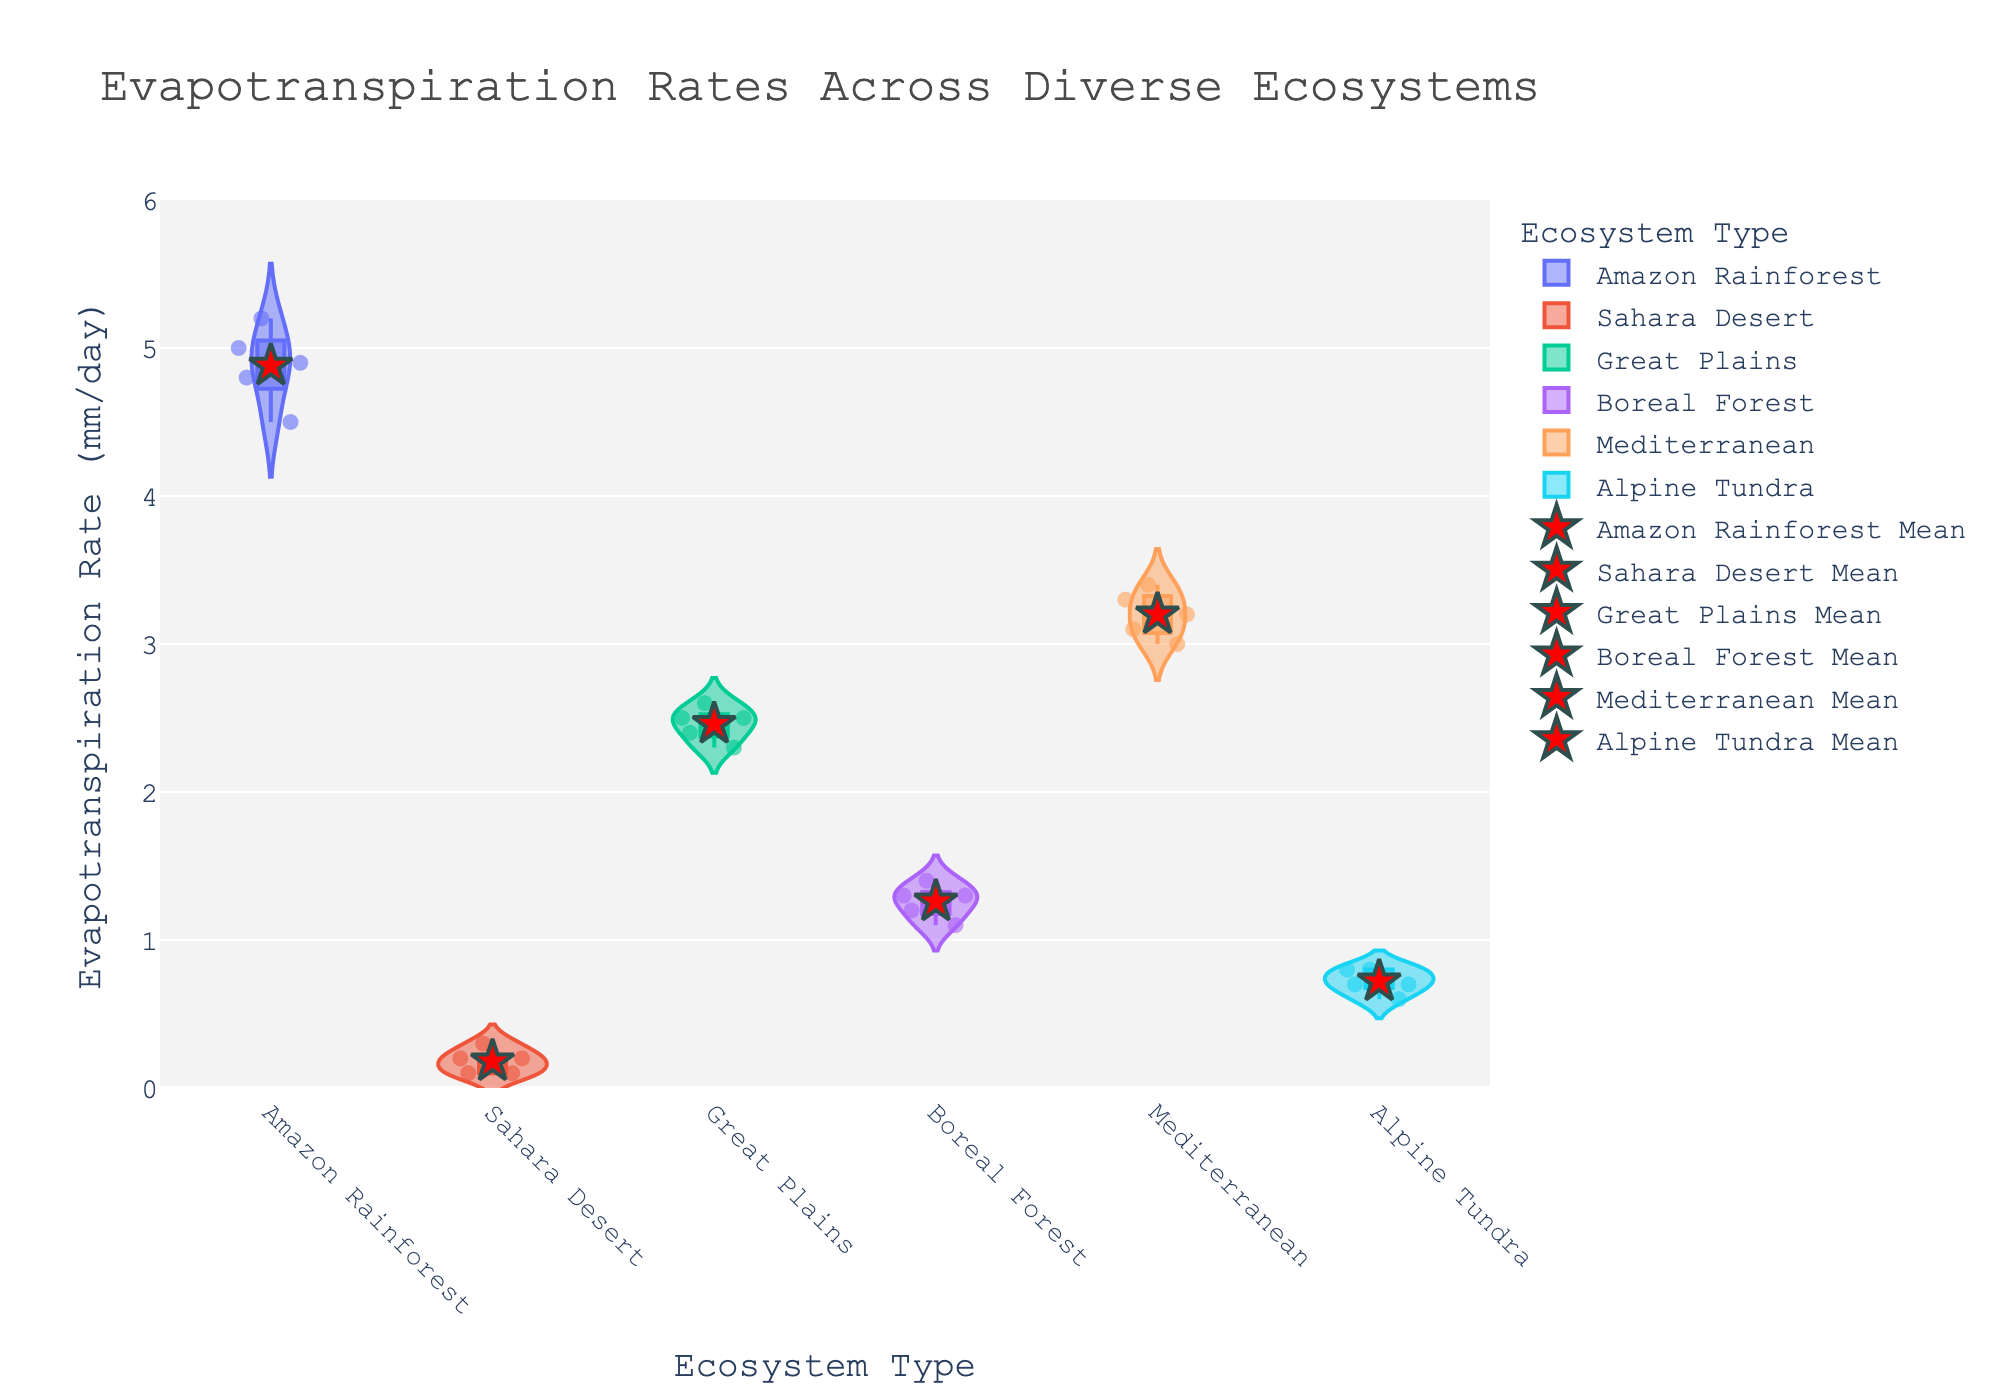What is the title of the figure? The title is usually located at the top of the figure and provides a succinct description of what the figure is about. In this case, it is "Evapotranspiration Rates Across Diverse Ecosystems"
Answer: Evapotranspiration Rates Across Diverse Ecosystems Which ecosystem has the highest average evapotranspiration rate? Look for the red star markers on the violin plots, which represent the mean values. The Amazon Rainforest has its marker at the highest point on the y-axis.
Answer: Amazon Rainforest What is the median evapotranspiration rate for the Sahara Desert? The box inside the violin plot displays the median value at the midpoint line. For the Sahara Desert, the median is at 0.2 mm/day.
Answer: 0.2 mm/day Which ecosystem has the widest distribution of evapotranspiration rates? Observing the width of the violin plots, the Amazon Rainforest has the widest spread, indicating the greatest variability in evapotranspiration rates.
Answer: Amazon Rainforest Compare the average evapotranspiration rates between the Great Plains and Mediterranean ecosystems. Which one is higher? Locate the red star markers for both ecosystems. The Mediterranean has a higher mean compared to the Great Plains.
Answer: Mediterranean What is the range of evapotranspiration rates for the Boreal Forest? The range can be determined by the lowest and highest points in the violin plot excluding outliers, which are approximately 1.1 to 1.4 mm/day for the Boreal Forest.
Answer: 1.1 to 1.4 mm/day How many data points are there for the Alpine Tundra? The number of individual points inside the violin plot provides this information. There are 5 data points in the Alpine Tundra violin plot.
Answer: 5 What is the interquartile range (IQR) for the Great Plains? The IQR is the range between the first quartile (Q1) and the third quartile (Q3) inside the box plot. For the Great Plains, Q1 is around 2.4 and Q3 is around 2.5, so IQR = 2.5 - 2.4.
Answer: 0.1 mm/day Is there any overlap in the distributions of evapotranspiration rates for the Sahara Desert and Alpine Tundra? Examine if the violin plots for these two ecosystems intersect on the y-axis. Yes, there is an overlap around the 0.6 - 0.8 mm/day range.
Answer: Yes Does the Amazon Rainforest exhibit more variance in evapotranspiration rates compared to the Boreal Forest? The width and spread of the violin plot indicate variance. The Amazon Rainforest violin plot is much wider and more spread out than the Boreal Forest's plot, indicating higher variance.
Answer: Yes 